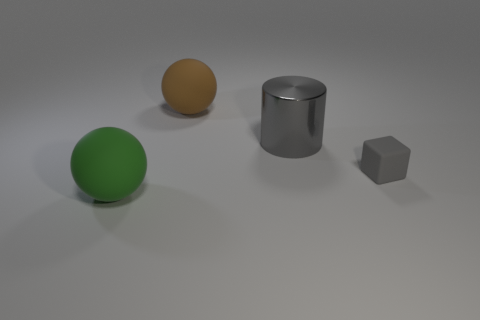What is the material of the cylinder?
Provide a succinct answer. Metal. There is a ball on the left side of the brown thing; is its size the same as the big brown object?
Make the answer very short. Yes. Are there any other things that are the same size as the brown ball?
Keep it short and to the point. Yes. The green object that is the same shape as the large brown matte object is what size?
Ensure brevity in your answer.  Large. Are there an equal number of large cylinders behind the gray metallic cylinder and small gray cubes behind the large brown thing?
Make the answer very short. Yes. What is the size of the object to the left of the large brown matte ball?
Provide a succinct answer. Large. Is the color of the metal object the same as the small matte object?
Ensure brevity in your answer.  Yes. Is there any other thing that has the same shape as the large brown rubber object?
Provide a short and direct response. Yes. What material is the big object that is the same color as the rubber block?
Provide a succinct answer. Metal. Is the number of big green matte objects that are right of the tiny matte object the same as the number of small blue cylinders?
Provide a short and direct response. Yes. 